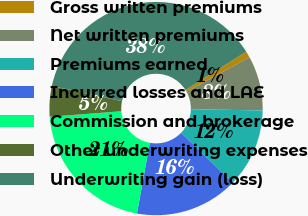<chart> <loc_0><loc_0><loc_500><loc_500><pie_chart><fcel>Gross written premiums<fcel>Net written premiums<fcel>Premiums earned<fcel>Incurred losses and LAE<fcel>Commission and brokerage<fcel>Other underwriting expenses<fcel>Underwriting gain (loss)<nl><fcel>0.95%<fcel>8.29%<fcel>11.96%<fcel>15.63%<fcel>20.91%<fcel>4.62%<fcel>37.64%<nl></chart> 